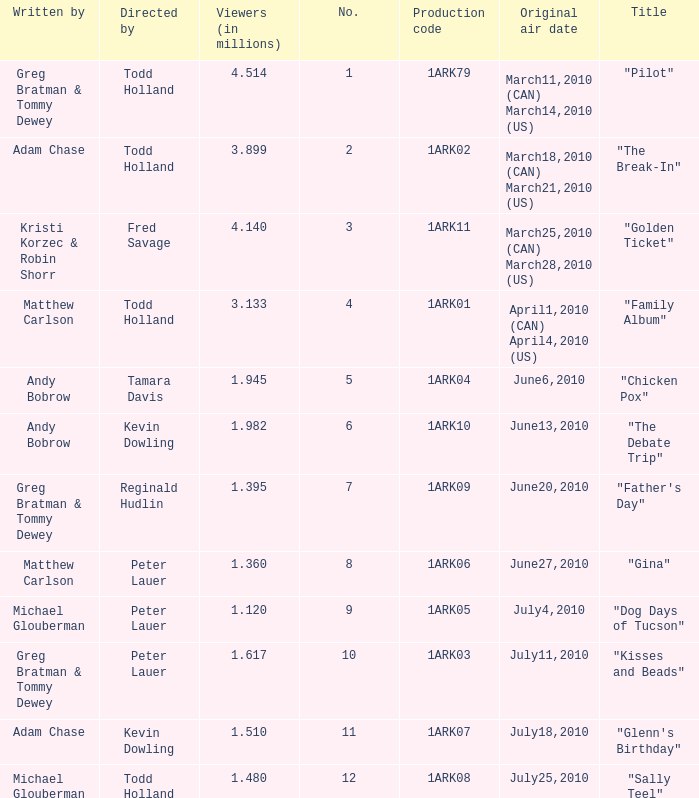How many directors were there for the production code 1ark08? 1.0. 